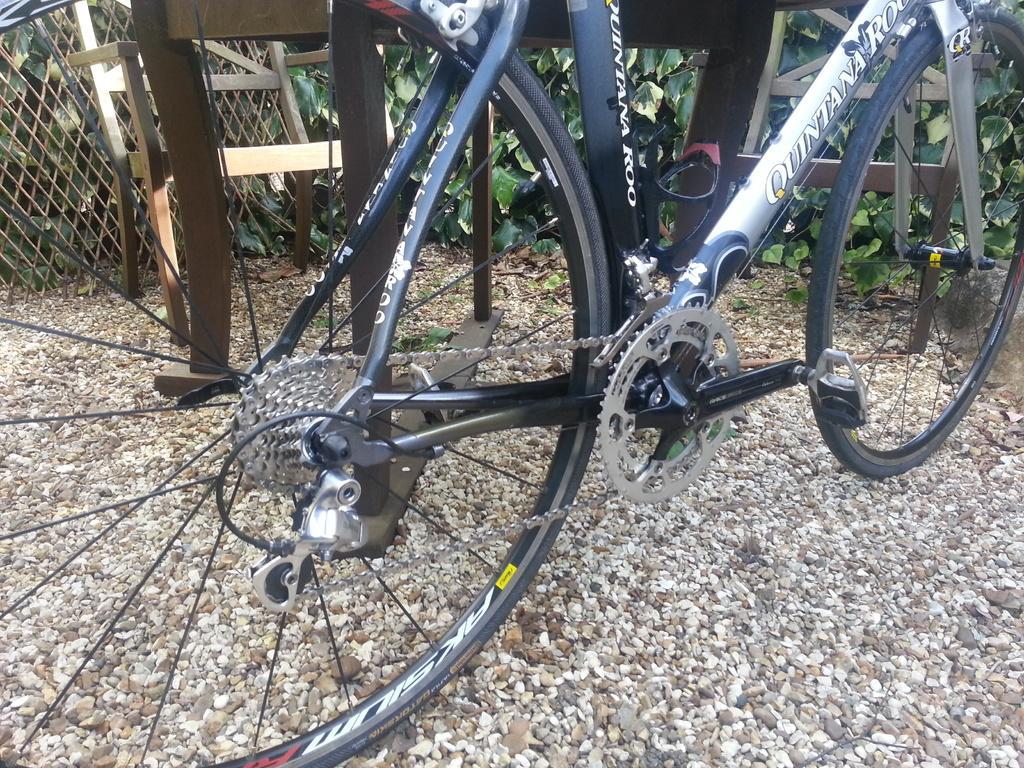How would you summarize this image in a sentence or two? In this image we can see a bicycle on the stones. In the background there are mesh, chair and plants. 